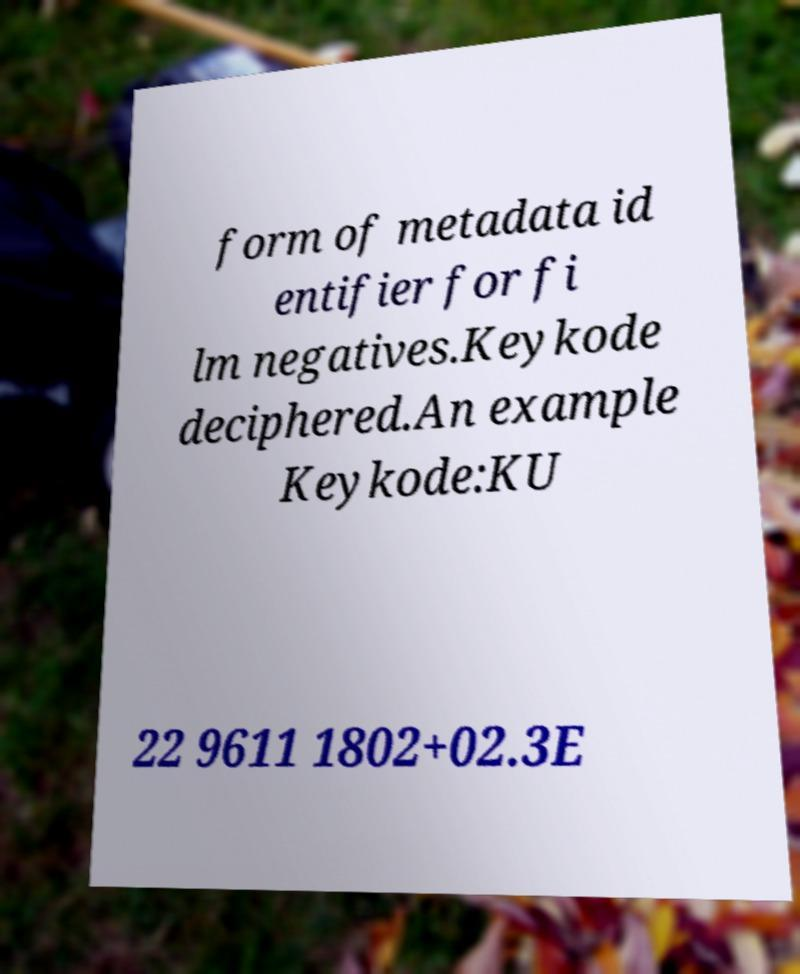What messages or text are displayed in this image? I need them in a readable, typed format. form of metadata id entifier for fi lm negatives.Keykode deciphered.An example Keykode:KU 22 9611 1802+02.3E 